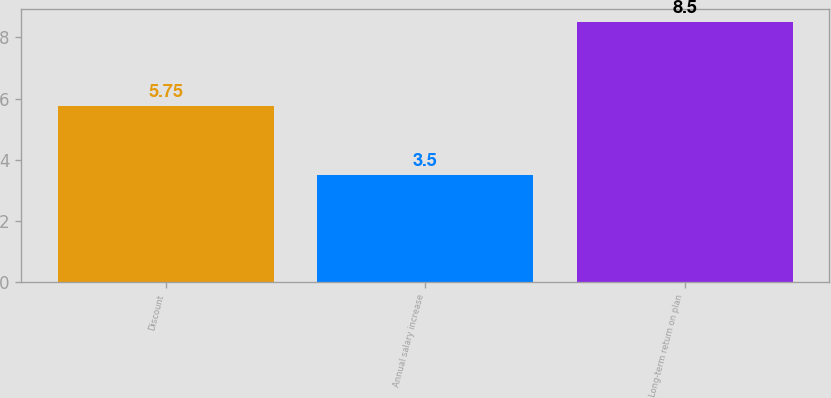<chart> <loc_0><loc_0><loc_500><loc_500><bar_chart><fcel>Discount<fcel>Annual salary increase<fcel>Long-term return on plan<nl><fcel>5.75<fcel>3.5<fcel>8.5<nl></chart> 